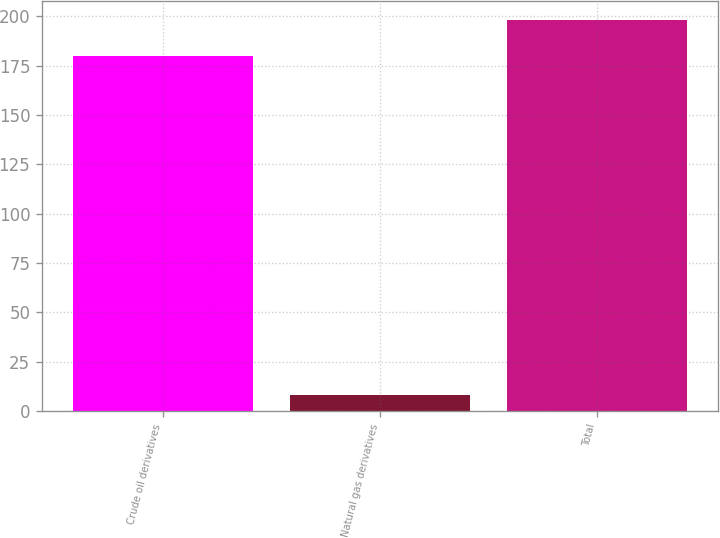<chart> <loc_0><loc_0><loc_500><loc_500><bar_chart><fcel>Crude oil derivatives<fcel>Natural gas derivatives<fcel>Total<nl><fcel>180<fcel>8<fcel>198<nl></chart> 